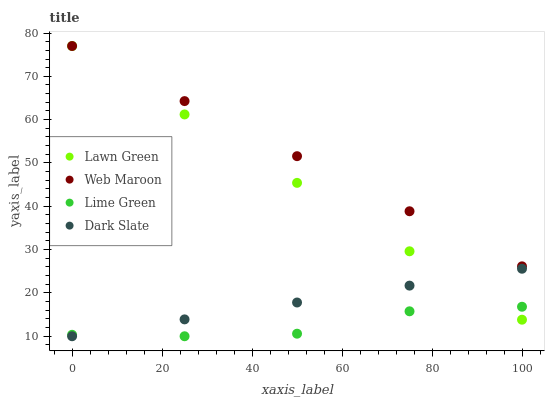Does Lime Green have the minimum area under the curve?
Answer yes or no. Yes. Does Web Maroon have the maximum area under the curve?
Answer yes or no. Yes. Does Web Maroon have the minimum area under the curve?
Answer yes or no. No. Does Lime Green have the maximum area under the curve?
Answer yes or no. No. Is Dark Slate the smoothest?
Answer yes or no. Yes. Is Lime Green the roughest?
Answer yes or no. Yes. Is Web Maroon the smoothest?
Answer yes or no. No. Is Web Maroon the roughest?
Answer yes or no. No. Does Lime Green have the lowest value?
Answer yes or no. Yes. Does Web Maroon have the lowest value?
Answer yes or no. No. Does Web Maroon have the highest value?
Answer yes or no. Yes. Does Lime Green have the highest value?
Answer yes or no. No. Is Dark Slate less than Web Maroon?
Answer yes or no. Yes. Is Web Maroon greater than Lime Green?
Answer yes or no. Yes. Does Lawn Green intersect Web Maroon?
Answer yes or no. Yes. Is Lawn Green less than Web Maroon?
Answer yes or no. No. Is Lawn Green greater than Web Maroon?
Answer yes or no. No. Does Dark Slate intersect Web Maroon?
Answer yes or no. No. 